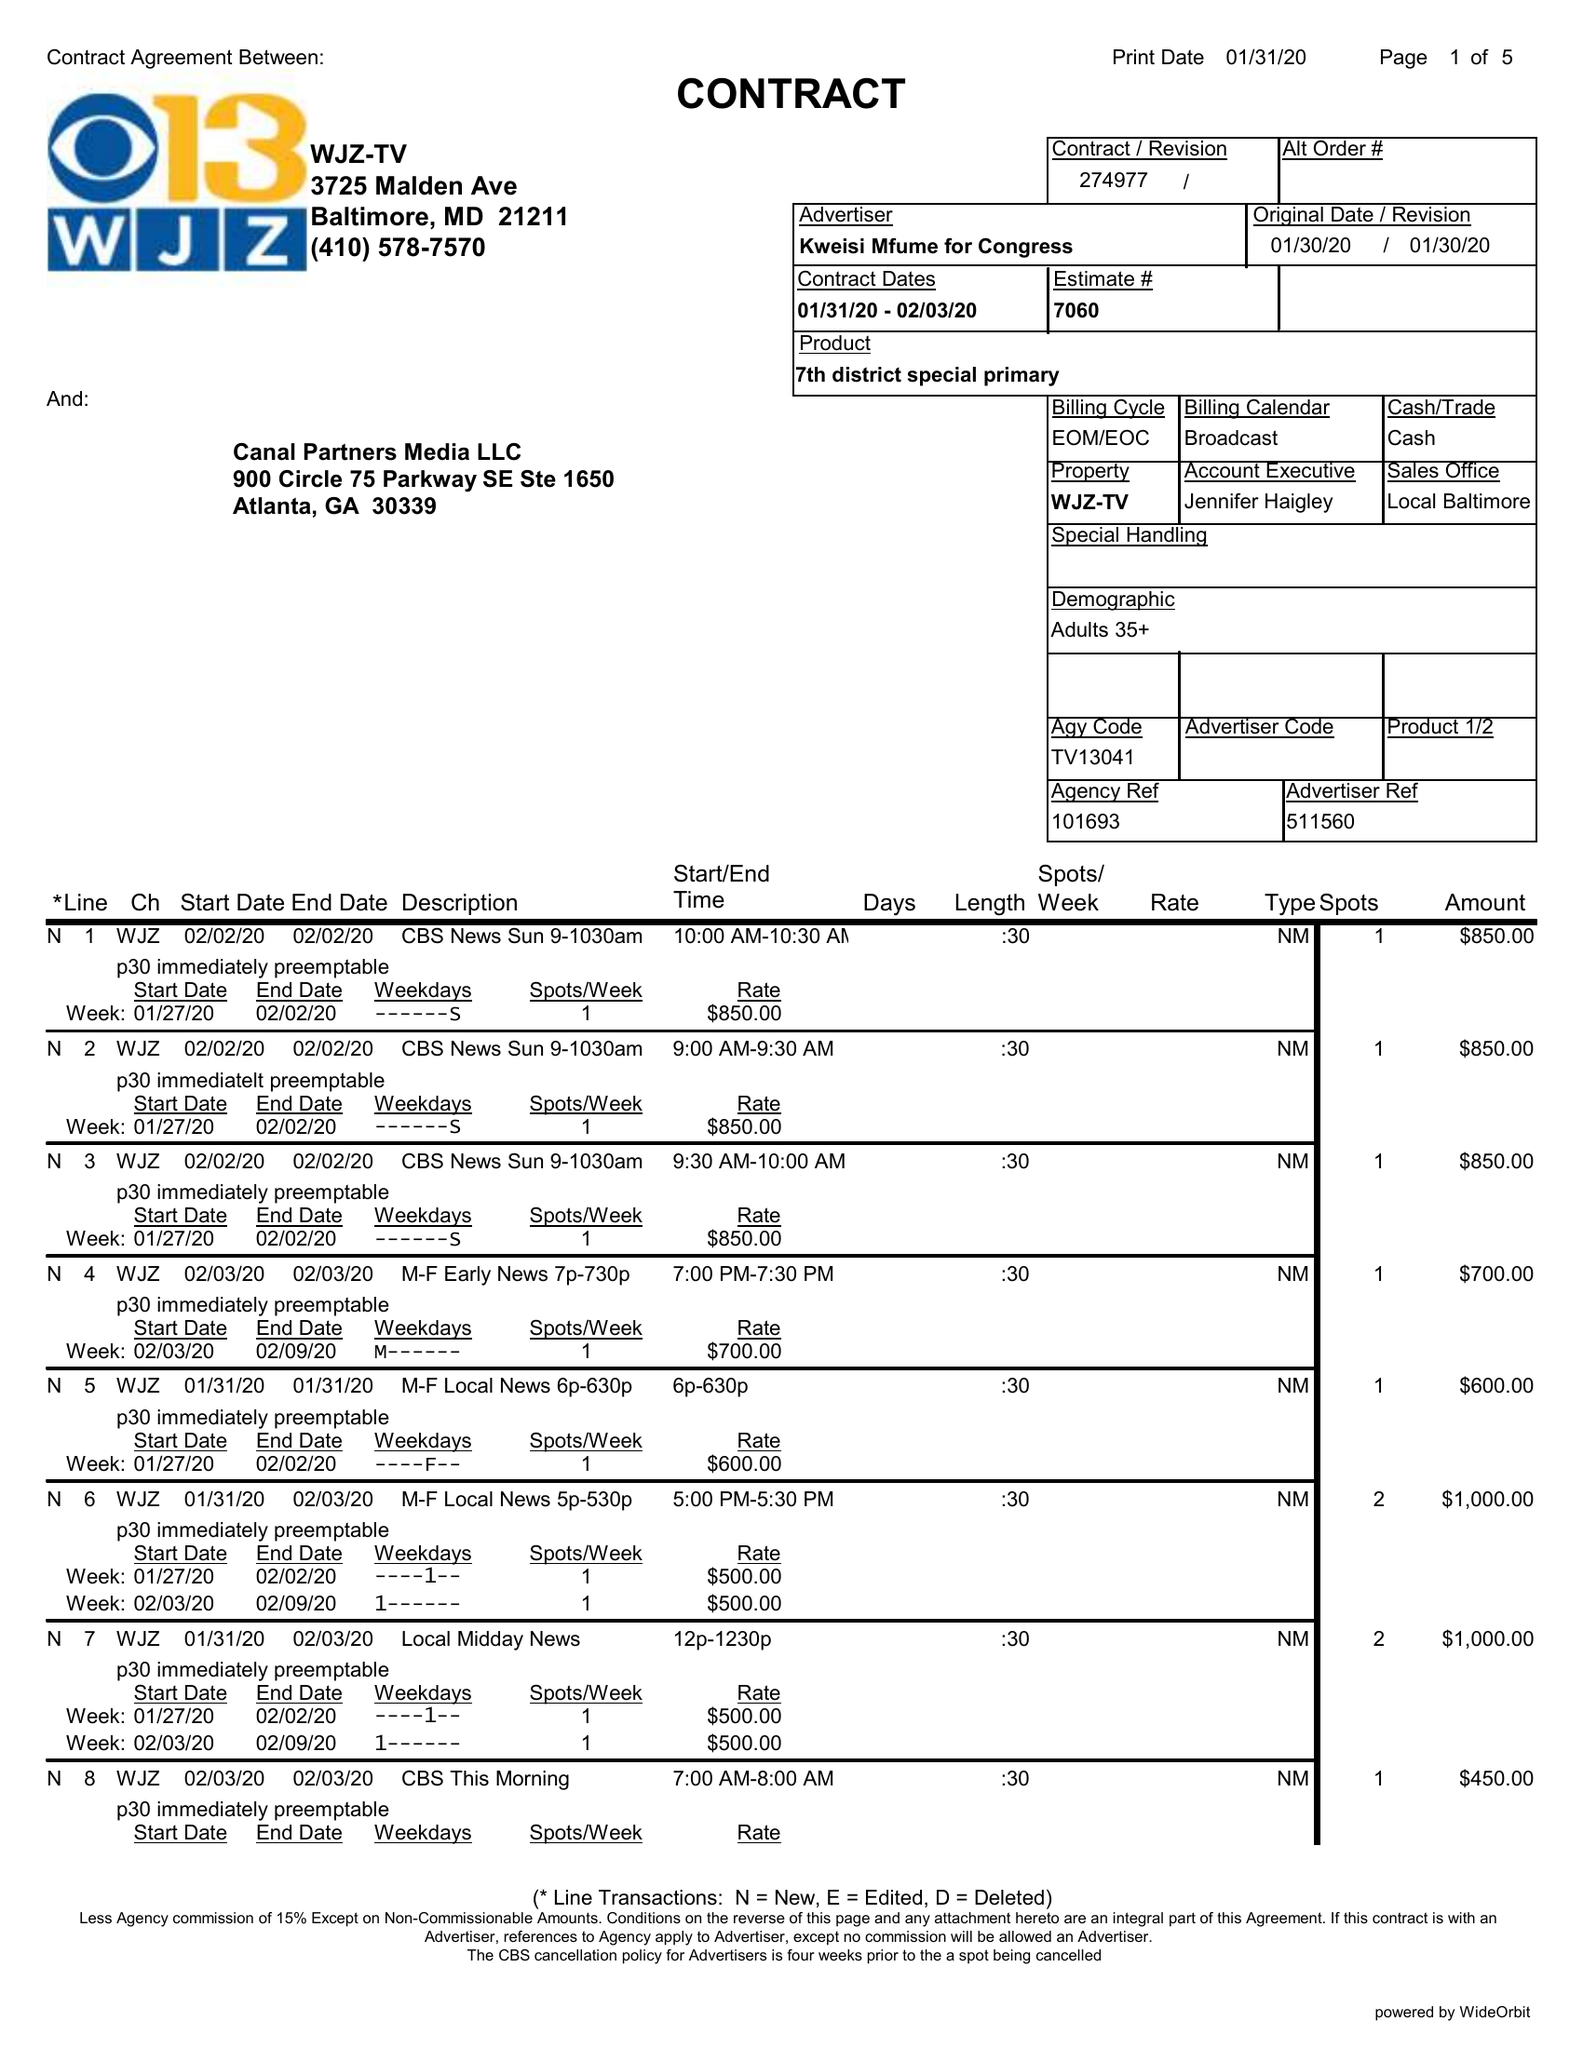What is the value for the flight_from?
Answer the question using a single word or phrase. 01/31/20 